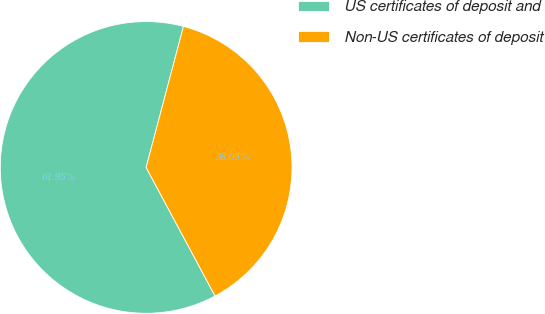Convert chart. <chart><loc_0><loc_0><loc_500><loc_500><pie_chart><fcel>US certificates of deposit and<fcel>Non-US certificates of deposit<nl><fcel>61.95%<fcel>38.05%<nl></chart> 